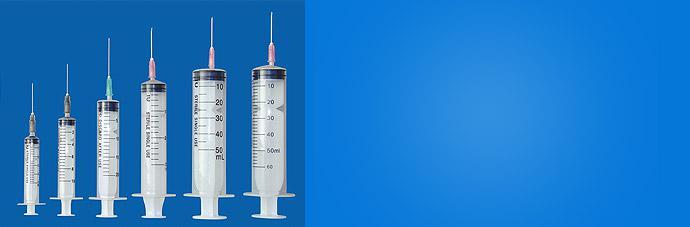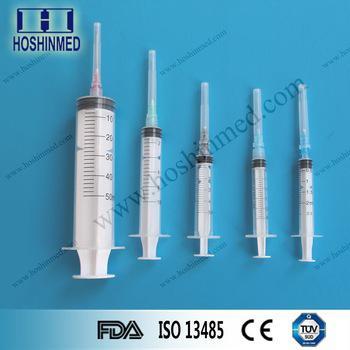The first image is the image on the left, the second image is the image on the right. Analyze the images presented: Is the assertion "There are seven syringes." valid? Answer yes or no. No. The first image is the image on the left, the second image is the image on the right. Analyze the images presented: Is the assertion "There is exactly one syringe with an uncapped needle." valid? Answer yes or no. No. 